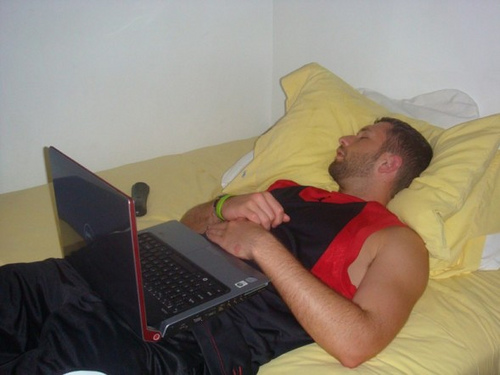Write a detailed description of the given image. A young man is lying on a spacious bed, appearing to be asleep. He is dressed in a sleeveless black and red sports jersey and matching shorts. On his lap is an open laptop, which is tilted slightly towards his left, facing upwards, indicating he might have been using it before dozing off. To his left, near the edge of the bed, is a remote control. The bed is adorned with yellow sheets and pillows: one is tucked under his head, another behind the first, and a large pillow is placed near the top right corner of the bed. The ambient lighting suggests a relaxed, homey atmosphere. 